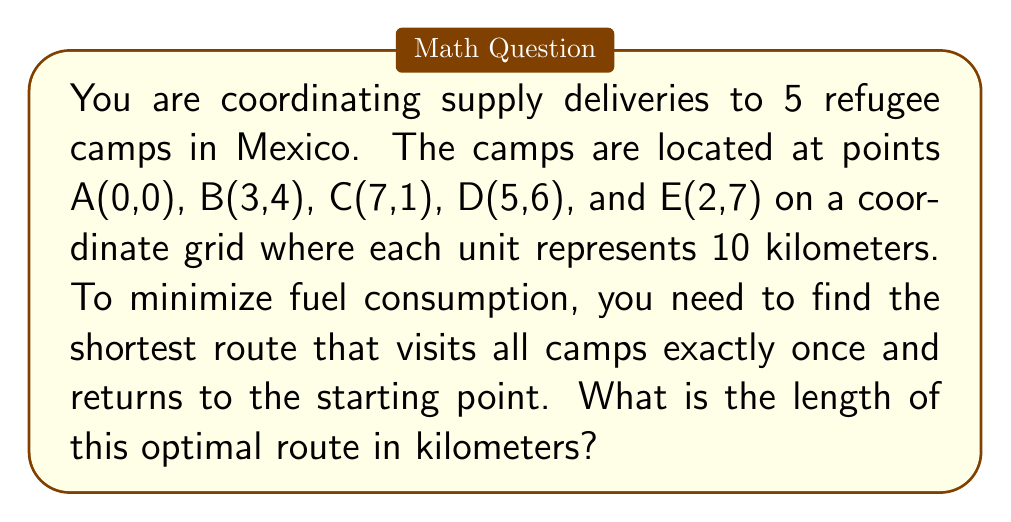Help me with this question. To solve this problem, we need to use the Traveling Salesman Problem (TSP) approach. Since there are only 5 points, we can use a brute-force method to find the shortest path.

Step 1: Calculate distances between all pairs of points using the distance formula:
$$d = \sqrt{(x_2-x_1)^2 + (y_2-y_1)^2}$$

AB = $\sqrt{(3-0)^2 + (4-0)^2} = 5$
AC = $\sqrt{(7-0)^2 + (1-0)^2} = \sqrt{50} \approx 7.07$
AD = $\sqrt{(5-0)^2 + (6-0)^2} = \sqrt{61} \approx 7.81$
AE = $\sqrt{(2-0)^2 + (7-0)^2} = \sqrt{53} \approx 7.28$
BC = $\sqrt{(7-3)^2 + (1-4)^2} = 5$
BD = $\sqrt{(5-3)^2 + (6-4)^2} = \sqrt{8} \approx 2.83$
BE = $\sqrt{(2-3)^2 + (7-4)^2} = \sqrt{10} \approx 3.16$
CD = $\sqrt{(5-7)^2 + (6-1)^2} = \sqrt{29} \approx 5.39$
CE = $\sqrt{(2-7)^2 + (7-1)^2} = \sqrt{61} \approx 7.81$
DE = $\sqrt{(2-5)^2 + (7-6)^2} = \sqrt{10} \approx 3.16$

Step 2: List all possible routes (there are 24 in total due to 4! permutations):
ABCDEA, ABCEDA, ABDCEA, ABDECA, ABEDCA, ABECDA, ...

Step 3: Calculate the total distance for each route and find the minimum.

The shortest route is AEDCBA with a total distance of:
AE + ED + DC + CB + BA = 7.28 + 3.16 + 5.39 + 5 + 5 = 25.83 units

Step 4: Convert the result to kilometers:
25.83 * 10 = 258.3 km

Therefore, the optimal route length is approximately 258.3 kilometers.
Answer: 258.3 km 